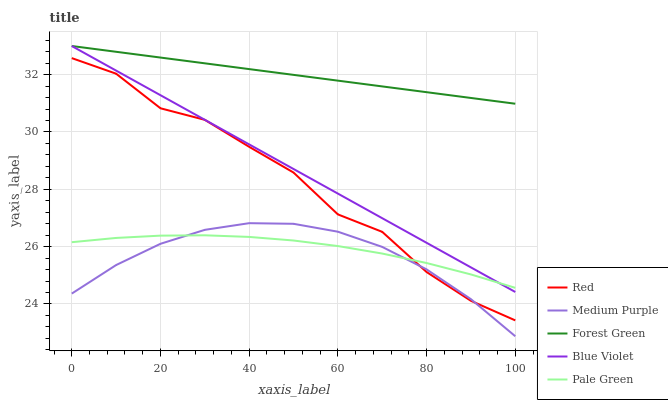Does Medium Purple have the minimum area under the curve?
Answer yes or no. Yes. Does Forest Green have the maximum area under the curve?
Answer yes or no. Yes. Does Pale Green have the minimum area under the curve?
Answer yes or no. No. Does Pale Green have the maximum area under the curve?
Answer yes or no. No. Is Blue Violet the smoothest?
Answer yes or no. Yes. Is Red the roughest?
Answer yes or no. Yes. Is Forest Green the smoothest?
Answer yes or no. No. Is Forest Green the roughest?
Answer yes or no. No. Does Medium Purple have the lowest value?
Answer yes or no. Yes. Does Pale Green have the lowest value?
Answer yes or no. No. Does Blue Violet have the highest value?
Answer yes or no. Yes. Does Pale Green have the highest value?
Answer yes or no. No. Is Pale Green less than Forest Green?
Answer yes or no. Yes. Is Forest Green greater than Medium Purple?
Answer yes or no. Yes. Does Red intersect Pale Green?
Answer yes or no. Yes. Is Red less than Pale Green?
Answer yes or no. No. Is Red greater than Pale Green?
Answer yes or no. No. Does Pale Green intersect Forest Green?
Answer yes or no. No. 